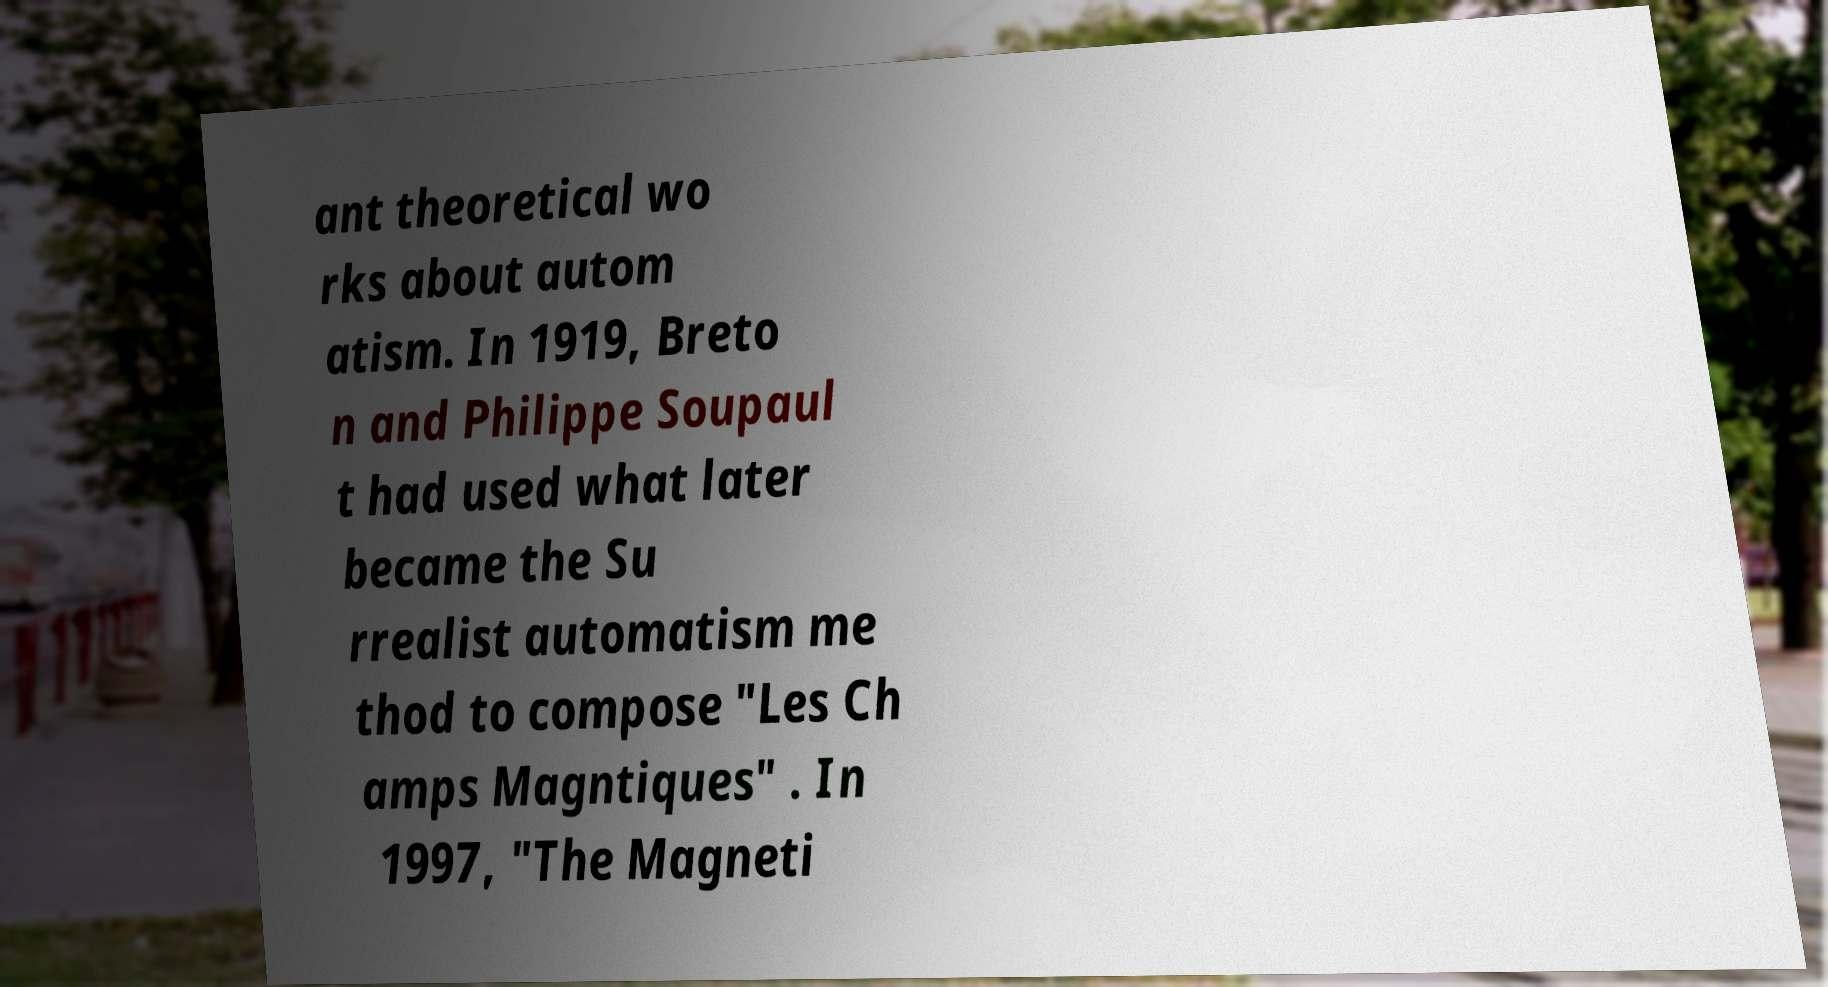What messages or text are displayed in this image? I need them in a readable, typed format. ant theoretical wo rks about autom atism. In 1919, Breto n and Philippe Soupaul t had used what later became the Su rrealist automatism me thod to compose "Les Ch amps Magntiques" . In 1997, "The Magneti 